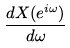<formula> <loc_0><loc_0><loc_500><loc_500>\frac { d X ( e ^ { i \omega } ) } { d \omega }</formula> 